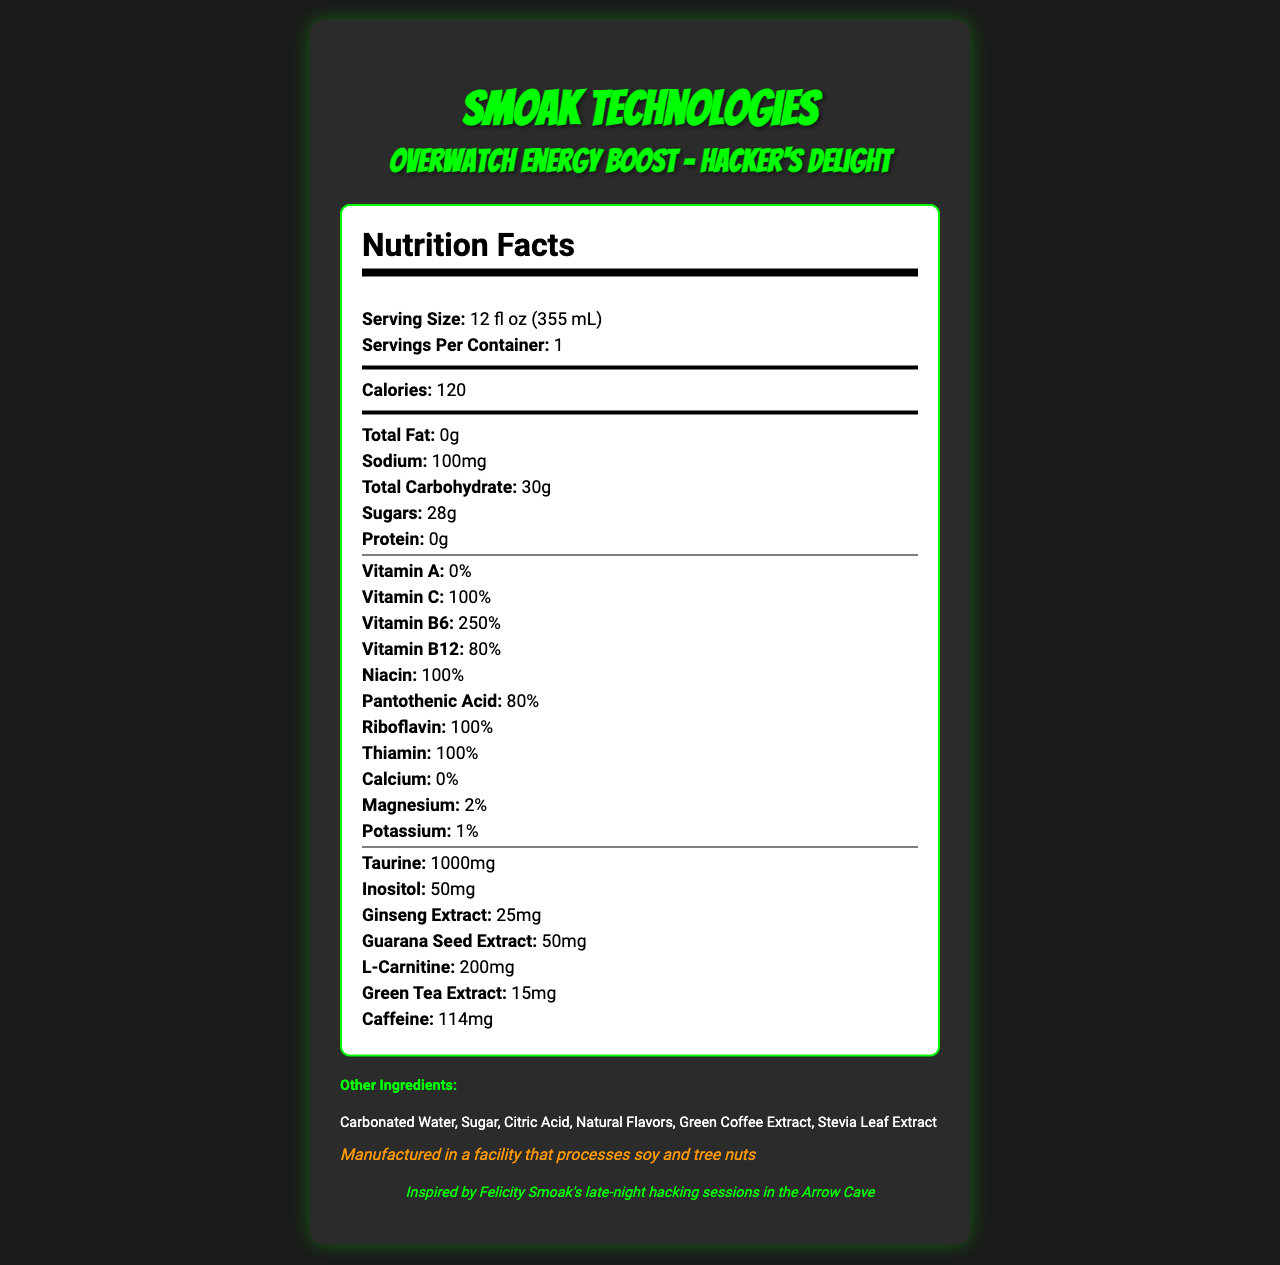what is the serving size of Overwatch Energy Boost? The document clearly states the serving size as 12 fl oz (355 mL).
Answer: 12 fl oz (355 mL) how many calories are in one serving of Hacker's Delight? The document lists the calories per serving as 120.
Answer: 120 how much vitamin C is in the drink? The Nutrition Facts section indicates that the drink contains 100% of the daily value of Vitamin C.
Answer: 100% list three main vitamins found in this energy drink. The Nutrition Facts section mentions various vitamins, including Vitamin C (100%), Vitamin B6 (250%), and Vitamin B12 (80%).
Answer: Vitamin C, Vitamin B6, and Vitamin B12 what is the sodium content of one serving? The document states that one serving contains 100mg of sodium.
Answer: 100mg which ingredient is not present in this drink? A. Taurine B. Vitamin D C. Ginseng Extract D. Inositol The document mentions Taurine, Ginseng Extract, and Inositol but does not list Vitamin D.
Answer: B. Vitamin D how many grams of sugar are in a serving? A. 20g B. 25g C. 28g D. 30g The document specifies that there are 28g of sugars per serving.
Answer: C. 28g is there any calcium in the drink? The Nutrition Facts clearly state that the calcium content is 0%.
Answer: No describe the allergen information provided. The document mentions that the energy drink is manufactured in a facility that processes soy and tree nuts.
Answer: Manufactured in a facility that processes soy and tree nuts how much caffeine does the drink contain? The document indicates that there are 114mg of caffeine per serving.
Answer: 114mg what is the primary flavor name of the energy drink? The document specifies that the flavor name is Hacker's Delight.
Answer: Hacker's Delight identify three other ingredients in the drink. The ingredients listed include Carbonated Water, Sugar, and Citric Acid among others.
Answer: Carbonated Water, Sugar, Citric Acid which vitamin is not present in the drink? The document states that Vitamin A content is 0%.
Answer: Vitamin A is there any protein in one serving? The Nutrition Facts state that the protein content is 0g per serving.
Answer: No what is the daily value percentage of Pantothenic Acid in the drink? The document lists Pantothenic Acid content as 80% of the daily value.
Answer: 80% list all the extracts found in Hacker's Delight. The document contains references to four extracts: Green Coffee Extract, Green Tea Extract, Ginseng Extract, and Guarana Seed Extract.
Answer: Green Coffee Extract, Green Tea Extract, Ginseng Extract, Guarana Seed Extract summarize the nutrition information and special notes about Overwatch Energy Boost. This answer summarizes all the essential nutritional information, highlights, and special notes provided in the document.
Answer: Overwatch Energy Boost by Smoak Technologies is an energy drink called Hacker's Delight. It has a serving size of 12 fl oz (355 mL) with 120 calories per serving. The drink contains 0g total fat, 100mg sodium, 30g total carbohydrates including 28g sugars, and 0g protein. Key vitamins and minerals include 100% Vitamin C, 250% Vitamin B6, 80% Vitamin B12, and several other B vitamins. The drink also contains taurine, inositol, ginseng extract, guarana seed extract, L-carnitine, green tea extract, and caffeine. It includes natural ingredients like Carbonated Water, Sugar, and Citric Acid, and is manufactured in a facility that processes soy and tree nuts. does this drink contain any fiber? The document does not provide any information on dietary fiber content.
Answer: Not mentioned which DC character is this drink’s inspiration rooted in? The document mentions that the drink is inspired by Felicity Smoak's late-night hacking sessions in the Arrow Cave.
Answer: Felicity Smoak 